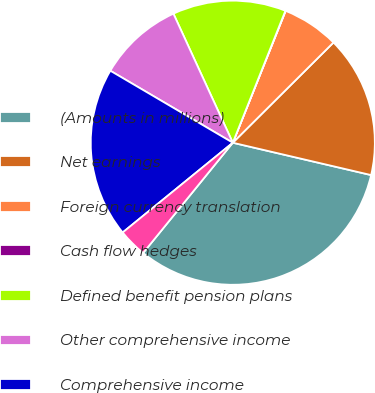Convert chart to OTSL. <chart><loc_0><loc_0><loc_500><loc_500><pie_chart><fcel>(Amounts in millions)<fcel>Net earnings<fcel>Foreign currency translation<fcel>Cash flow hedges<fcel>Defined benefit pension plans<fcel>Other comprehensive income<fcel>Comprehensive income<fcel>Less comprehensive (income)<nl><fcel>32.21%<fcel>16.12%<fcel>6.47%<fcel>0.03%<fcel>12.9%<fcel>9.68%<fcel>19.34%<fcel>3.25%<nl></chart> 